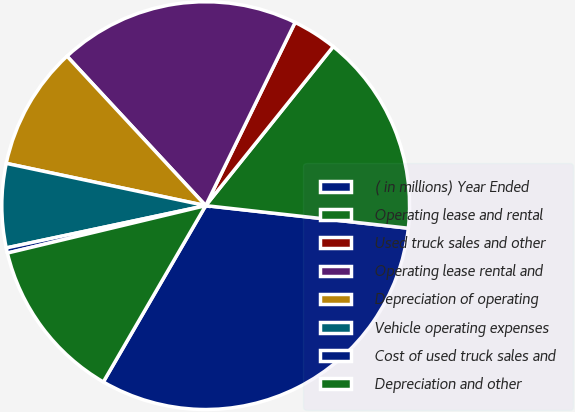Convert chart to OTSL. <chart><loc_0><loc_0><loc_500><loc_500><pie_chart><fcel>( in millions) Year Ended<fcel>Operating lease and rental<fcel>Used truck sales and other<fcel>Operating lease rental and<fcel>Depreciation of operating<fcel>Vehicle operating expenses<fcel>Cost of used truck sales and<fcel>Depreciation and other<nl><fcel>31.6%<fcel>16.01%<fcel>3.53%<fcel>19.13%<fcel>9.77%<fcel>6.65%<fcel>0.41%<fcel>12.89%<nl></chart> 